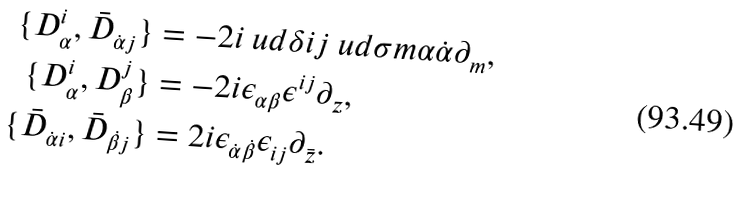Convert formula to latex. <formula><loc_0><loc_0><loc_500><loc_500>\{ D _ { \alpha } ^ { i } , \bar { D } _ { \dot { \alpha } j } \} & = - 2 i \ u d \delta i j \ u d \sigma m { \alpha \dot { \alpha } } \partial _ { m } , \\ \{ D _ { \alpha } ^ { i } , D _ { \beta } ^ { j } \} & = - 2 i \epsilon _ { \alpha \beta } \epsilon ^ { i j } \partial _ { z } , \\ \{ \bar { D } _ { \dot { \alpha } i } , \bar { D } _ { \dot { \beta } j } \} & = 2 i \epsilon _ { \dot { \alpha } \dot { \beta } } \epsilon _ { i j } \partial _ { \bar { z } } .</formula> 